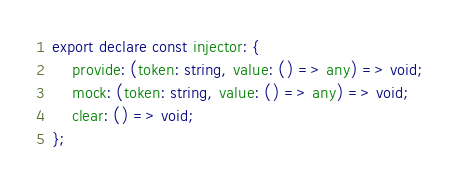Convert code to text. <code><loc_0><loc_0><loc_500><loc_500><_TypeScript_>export declare const injector: {
    provide: (token: string, value: () => any) => void;
    mock: (token: string, value: () => any) => void;
    clear: () => void;
};
</code> 